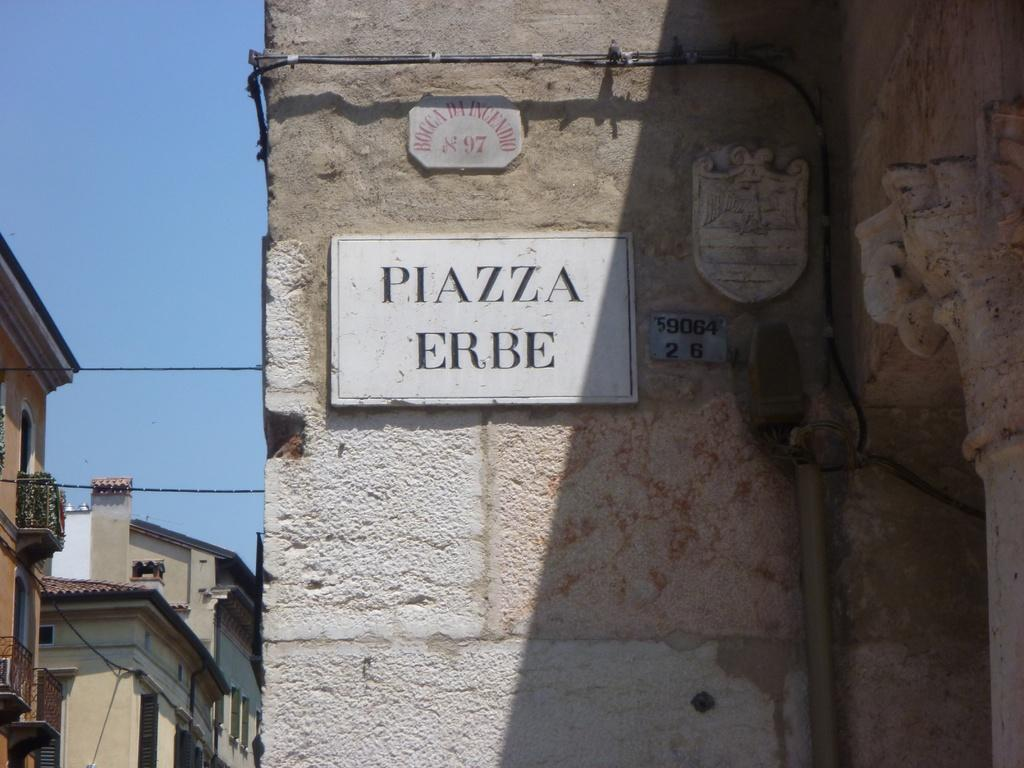What is attached to the building in the image? There is a number plate and name boards attached to the building in the image. Where are the number plate and name boards located in relation to each other? The number plate and name boards are near each other in the image. What is present near the number plate and name boards? Cables are present near the number plate and name boards. What can be seen in the background of the image? Electrical lines, buildings, and a blue sky are visible in the background of the image. How many twigs are present on the name boards in the image? There are no twigs present on the name boards in the image. What type of trees can be seen near the buildings in the background? There are no trees visible in the image; only buildings and electrical lines are present in the background. 